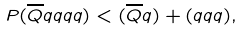<formula> <loc_0><loc_0><loc_500><loc_500>P ( \overline { Q } q q q q ) < ( \overline { Q } q ) + ( q q q ) ,</formula> 